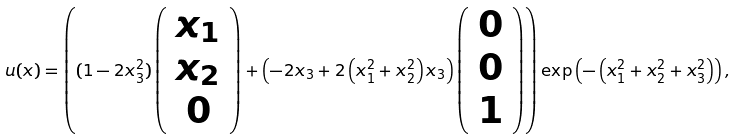Convert formula to latex. <formula><loc_0><loc_0><loc_500><loc_500>u ( x ) = \left ( ( 1 - 2 x _ { 3 } ^ { 2 } ) \left ( \begin{array} { c } x _ { 1 } \\ x _ { 2 } \\ 0 \end{array} \right ) + \left ( - 2 x _ { 3 } + 2 \left ( x _ { 1 } ^ { 2 } + x _ { 2 } ^ { 2 } \right ) x _ { 3 } \right ) \left ( \begin{array} { c } 0 \\ 0 \\ 1 \end{array} \right ) \right ) \exp \left ( - \left ( x _ { 1 } ^ { 2 } + x _ { 2 } ^ { 2 } + x _ { 3 } ^ { 2 } \right ) \right ) ,</formula> 